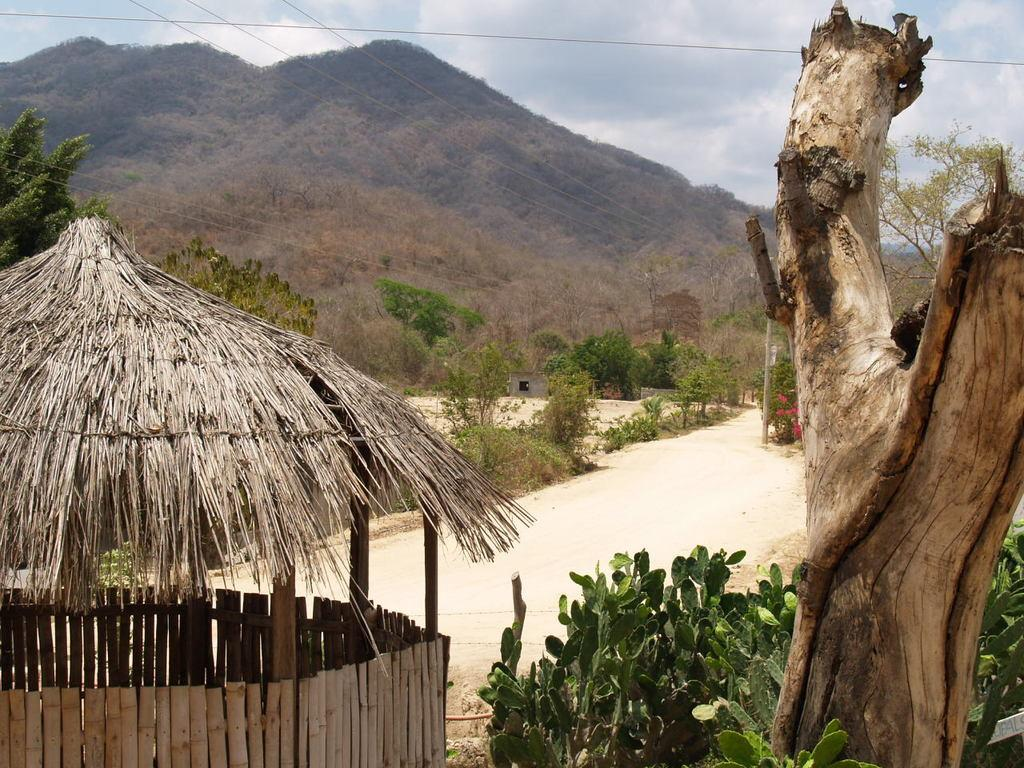What type of structure is present in the image? There is a hut in the image. What other natural elements can be seen in the image? There are plants, trees, and a mountain covered with trees in the image. What type of path is visible in the image? There is a mud road in the image. Where is the spy hiding in the image? There is no spy present in the image. What type of nest can be seen in the image? There is no nest present in the image. 